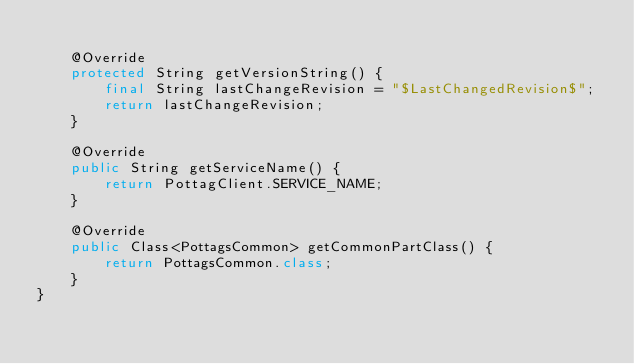<code> <loc_0><loc_0><loc_500><loc_500><_Java_>
    @Override
    protected String getVersionString() {
    	final String lastChangeRevision = "$LastChangedRevision$";
    	return lastChangeRevision;
    }
    
    @Override
    public String getServiceName() {
        return PottagClient.SERVICE_NAME;
    }

    @Override
    public Class<PottagsCommon> getCommonPartClass() {
    	return PottagsCommon.class;
    }
}






</code> 